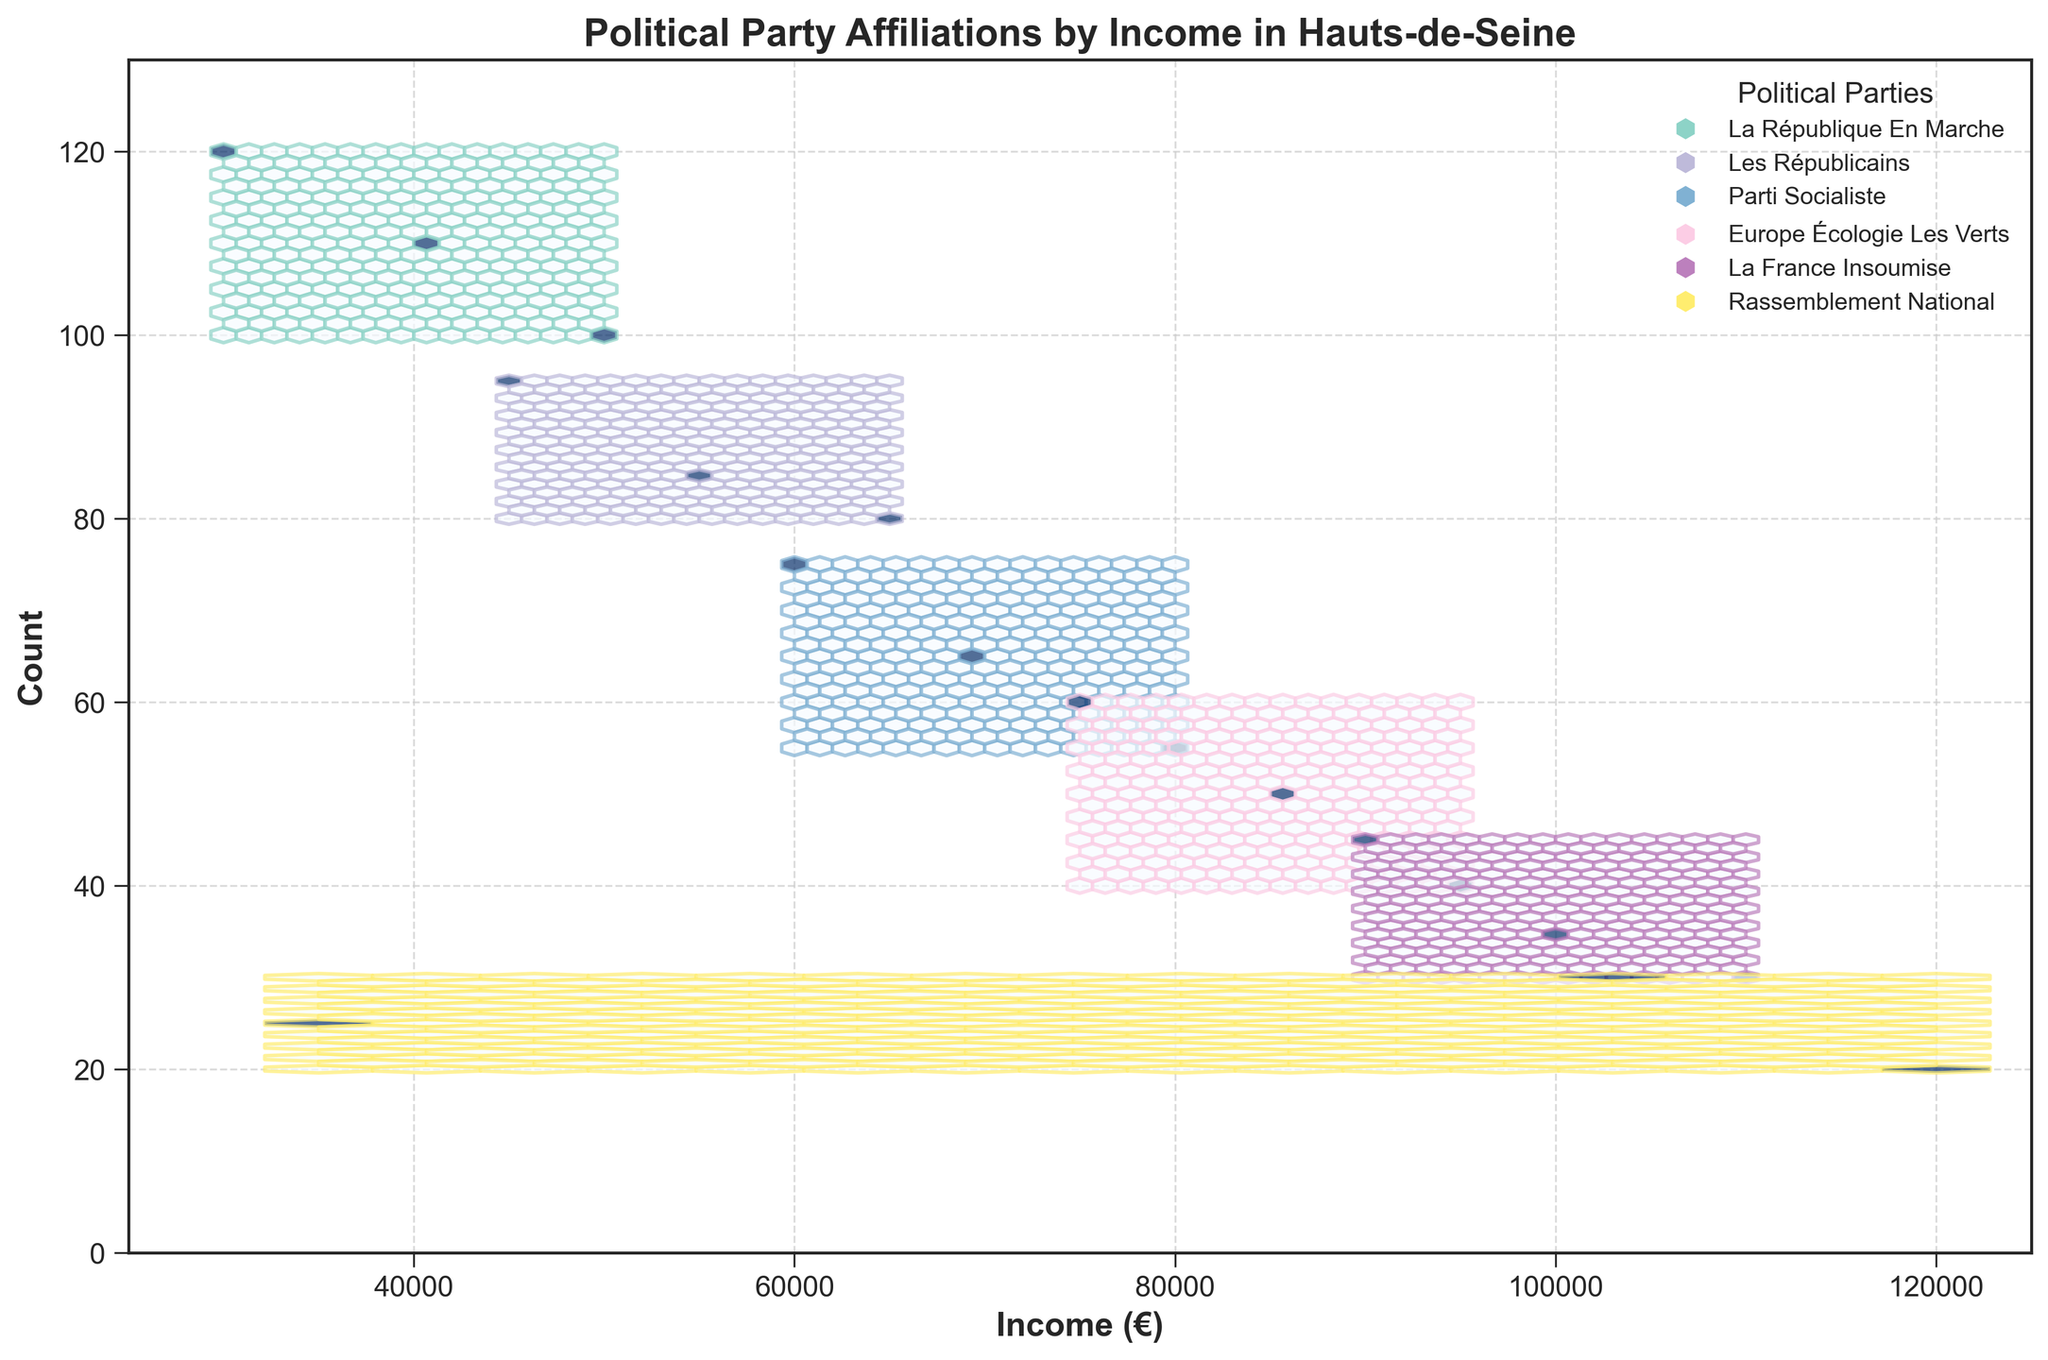What is the title of the plot? The title of the plot can be easily read from the top of the figure. It is explicitly stated and usually provides a summary of what the visual representation is about.
Answer: Political Party Affiliations by Income in Hauts-de-Seine What is the y-axis labeled as? The y-axis label is typically written vertically along the y-axis itself and indicates what the y-axis values represent.
Answer: Count Which political party has the highest affiliation in the lowest income bracket (around €30,000 - €40,000)? By examining the hexagonal bins around the €30,000 - €40,000 income range, observe which color dominates or shows the highest density of counts.
Answer: La République En Marche Is there any political party with no representation in the income bracket around €100,000 - €110,000? By looking at the bins corresponding to the €100,000 - €110,000 income range, check if there are any distinct political party colors missing.
Answer: Yes, Rassemblement National Which political party shows a decreasing trend with increasing income? Observe the hexbin plot for a political party where the count of affiliations decreases as income levels increase. This can be identified by the fading color intensity in hexagons from left to right.
Answer: La République En Marche What is the range of income values displayed on the x-axis? This can be determined by reading the minimum and maximum values on the x-axis, which are set explicitly on the axis ranges.
Answer: €25000 - €125000 What's the total count for "La République En Marche" in the income range of €30,000 to €40,000? Locate the hexagonal bins for "La République En Marche" within the €30,000 to €40,000 range and sum up the counts indicated by those bins. The counts can be approximated based on bin density and provided data values. There's one bin of 120 and another of 110 in this range.
Answer: 230 Which political party has the lowest affiliation count in the highest income bracket (around €120,000)? By examining the highest income range around €120,000, observe the count values and identify which political party has the least dense or smallest value bin.
Answer: Rassemblement National How does the size of the hexagons change across the plot, and what does this indicate? The size of hexagons generally remains consistent but the color intensity changes based on density. Smaller, denser hexagons indicate higher counts, while larger, less dense hexagons indicate lower counts. This size consistency and color variation helps in understanding the distribution of affiliations.
Answer: Consistent size, color varies for density Do any political parties have overlapping bins, and what might this indicate about their voter base? Analyze the hexagonal bins and identify any overlaps between different political party colors which suggest that voters from different income levels within similar ranges might be choosing different parties.
Answer: Yes, overlapping means diverse voter bases 